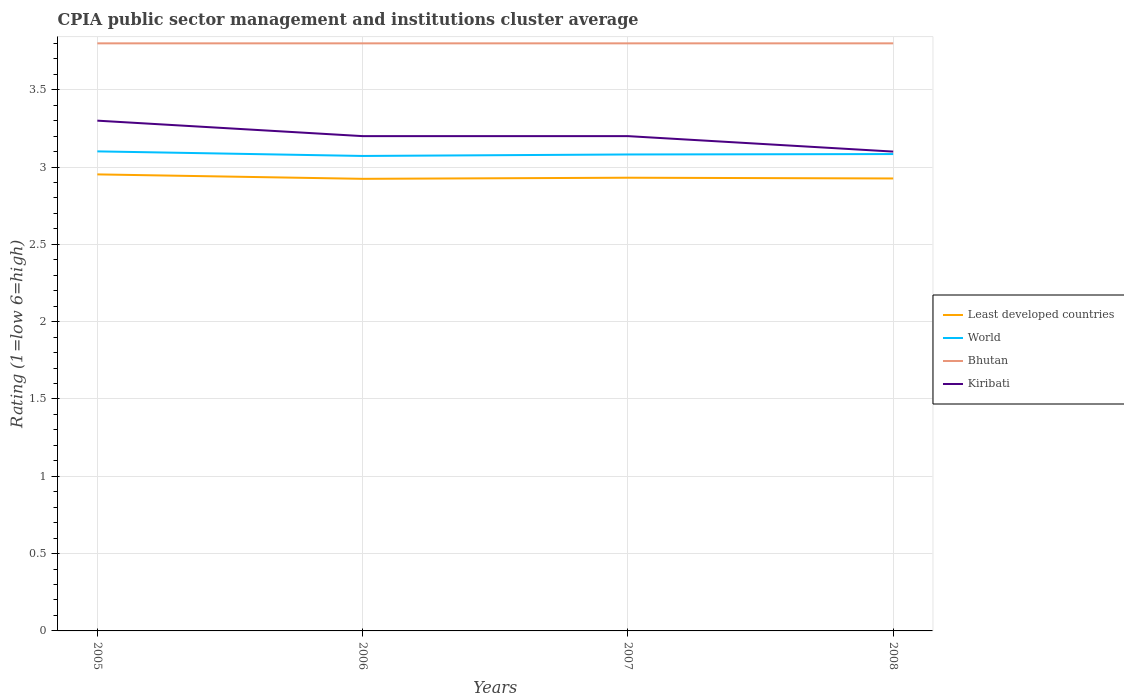How many different coloured lines are there?
Make the answer very short. 4. Does the line corresponding to Kiribati intersect with the line corresponding to World?
Keep it short and to the point. No. Across all years, what is the maximum CPIA rating in World?
Keep it short and to the point. 3.07. What is the total CPIA rating in Least developed countries in the graph?
Your answer should be very brief. -0. What is the difference between the highest and the second highest CPIA rating in Bhutan?
Keep it short and to the point. 0. Is the CPIA rating in Least developed countries strictly greater than the CPIA rating in World over the years?
Keep it short and to the point. Yes. How many lines are there?
Offer a very short reply. 4. How many years are there in the graph?
Provide a succinct answer. 4. What is the difference between two consecutive major ticks on the Y-axis?
Your response must be concise. 0.5. Where does the legend appear in the graph?
Offer a very short reply. Center right. What is the title of the graph?
Your answer should be compact. CPIA public sector management and institutions cluster average. What is the label or title of the X-axis?
Your answer should be compact. Years. What is the label or title of the Y-axis?
Your answer should be very brief. Rating (1=low 6=high). What is the Rating (1=low 6=high) of Least developed countries in 2005?
Ensure brevity in your answer.  2.95. What is the Rating (1=low 6=high) of World in 2005?
Provide a succinct answer. 3.1. What is the Rating (1=low 6=high) of Least developed countries in 2006?
Provide a short and direct response. 2.92. What is the Rating (1=low 6=high) in World in 2006?
Your answer should be compact. 3.07. What is the Rating (1=low 6=high) of Bhutan in 2006?
Your answer should be very brief. 3.8. What is the Rating (1=low 6=high) of Least developed countries in 2007?
Give a very brief answer. 2.93. What is the Rating (1=low 6=high) in World in 2007?
Ensure brevity in your answer.  3.08. What is the Rating (1=low 6=high) in Kiribati in 2007?
Your response must be concise. 3.2. What is the Rating (1=low 6=high) of Least developed countries in 2008?
Your answer should be very brief. 2.93. What is the Rating (1=low 6=high) of World in 2008?
Make the answer very short. 3.08. Across all years, what is the maximum Rating (1=low 6=high) of Least developed countries?
Provide a succinct answer. 2.95. Across all years, what is the maximum Rating (1=low 6=high) in World?
Offer a terse response. 3.1. Across all years, what is the maximum Rating (1=low 6=high) in Bhutan?
Offer a very short reply. 3.8. Across all years, what is the maximum Rating (1=low 6=high) of Kiribati?
Your response must be concise. 3.3. Across all years, what is the minimum Rating (1=low 6=high) in Least developed countries?
Give a very brief answer. 2.92. Across all years, what is the minimum Rating (1=low 6=high) in World?
Provide a succinct answer. 3.07. What is the total Rating (1=low 6=high) in Least developed countries in the graph?
Your response must be concise. 11.73. What is the total Rating (1=low 6=high) of World in the graph?
Your response must be concise. 12.34. What is the difference between the Rating (1=low 6=high) in Least developed countries in 2005 and that in 2006?
Offer a very short reply. 0.03. What is the difference between the Rating (1=low 6=high) in World in 2005 and that in 2006?
Your answer should be compact. 0.03. What is the difference between the Rating (1=low 6=high) in Bhutan in 2005 and that in 2006?
Provide a short and direct response. 0. What is the difference between the Rating (1=low 6=high) in Least developed countries in 2005 and that in 2007?
Make the answer very short. 0.02. What is the difference between the Rating (1=low 6=high) in World in 2005 and that in 2007?
Give a very brief answer. 0.02. What is the difference between the Rating (1=low 6=high) in Bhutan in 2005 and that in 2007?
Ensure brevity in your answer.  0. What is the difference between the Rating (1=low 6=high) of Kiribati in 2005 and that in 2007?
Provide a short and direct response. 0.1. What is the difference between the Rating (1=low 6=high) of Least developed countries in 2005 and that in 2008?
Give a very brief answer. 0.03. What is the difference between the Rating (1=low 6=high) in World in 2005 and that in 2008?
Provide a succinct answer. 0.02. What is the difference between the Rating (1=low 6=high) in Bhutan in 2005 and that in 2008?
Give a very brief answer. 0. What is the difference between the Rating (1=low 6=high) of Least developed countries in 2006 and that in 2007?
Your answer should be very brief. -0.01. What is the difference between the Rating (1=low 6=high) of World in 2006 and that in 2007?
Offer a terse response. -0.01. What is the difference between the Rating (1=low 6=high) of Bhutan in 2006 and that in 2007?
Your answer should be very brief. 0. What is the difference between the Rating (1=low 6=high) of Kiribati in 2006 and that in 2007?
Offer a terse response. 0. What is the difference between the Rating (1=low 6=high) of Least developed countries in 2006 and that in 2008?
Offer a very short reply. -0. What is the difference between the Rating (1=low 6=high) of World in 2006 and that in 2008?
Provide a short and direct response. -0.01. What is the difference between the Rating (1=low 6=high) in Kiribati in 2006 and that in 2008?
Your response must be concise. 0.1. What is the difference between the Rating (1=low 6=high) in Least developed countries in 2007 and that in 2008?
Your response must be concise. 0. What is the difference between the Rating (1=low 6=high) in World in 2007 and that in 2008?
Offer a very short reply. -0. What is the difference between the Rating (1=low 6=high) in Bhutan in 2007 and that in 2008?
Your response must be concise. 0. What is the difference between the Rating (1=low 6=high) in Least developed countries in 2005 and the Rating (1=low 6=high) in World in 2006?
Your answer should be compact. -0.12. What is the difference between the Rating (1=low 6=high) of Least developed countries in 2005 and the Rating (1=low 6=high) of Bhutan in 2006?
Give a very brief answer. -0.85. What is the difference between the Rating (1=low 6=high) in Least developed countries in 2005 and the Rating (1=low 6=high) in Kiribati in 2006?
Your answer should be compact. -0.25. What is the difference between the Rating (1=low 6=high) in World in 2005 and the Rating (1=low 6=high) in Bhutan in 2006?
Your response must be concise. -0.7. What is the difference between the Rating (1=low 6=high) in World in 2005 and the Rating (1=low 6=high) in Kiribati in 2006?
Provide a succinct answer. -0.1. What is the difference between the Rating (1=low 6=high) in Least developed countries in 2005 and the Rating (1=low 6=high) in World in 2007?
Provide a succinct answer. -0.13. What is the difference between the Rating (1=low 6=high) of Least developed countries in 2005 and the Rating (1=low 6=high) of Bhutan in 2007?
Provide a succinct answer. -0.85. What is the difference between the Rating (1=low 6=high) of Least developed countries in 2005 and the Rating (1=low 6=high) of Kiribati in 2007?
Give a very brief answer. -0.25. What is the difference between the Rating (1=low 6=high) in World in 2005 and the Rating (1=low 6=high) in Bhutan in 2007?
Ensure brevity in your answer.  -0.7. What is the difference between the Rating (1=low 6=high) in World in 2005 and the Rating (1=low 6=high) in Kiribati in 2007?
Provide a short and direct response. -0.1. What is the difference between the Rating (1=low 6=high) in Least developed countries in 2005 and the Rating (1=low 6=high) in World in 2008?
Give a very brief answer. -0.13. What is the difference between the Rating (1=low 6=high) of Least developed countries in 2005 and the Rating (1=low 6=high) of Bhutan in 2008?
Make the answer very short. -0.85. What is the difference between the Rating (1=low 6=high) of Least developed countries in 2005 and the Rating (1=low 6=high) of Kiribati in 2008?
Make the answer very short. -0.15. What is the difference between the Rating (1=low 6=high) of World in 2005 and the Rating (1=low 6=high) of Bhutan in 2008?
Provide a short and direct response. -0.7. What is the difference between the Rating (1=low 6=high) in World in 2005 and the Rating (1=low 6=high) in Kiribati in 2008?
Offer a very short reply. 0. What is the difference between the Rating (1=low 6=high) in Bhutan in 2005 and the Rating (1=low 6=high) in Kiribati in 2008?
Ensure brevity in your answer.  0.7. What is the difference between the Rating (1=low 6=high) of Least developed countries in 2006 and the Rating (1=low 6=high) of World in 2007?
Provide a short and direct response. -0.16. What is the difference between the Rating (1=low 6=high) of Least developed countries in 2006 and the Rating (1=low 6=high) of Bhutan in 2007?
Provide a short and direct response. -0.88. What is the difference between the Rating (1=low 6=high) of Least developed countries in 2006 and the Rating (1=low 6=high) of Kiribati in 2007?
Ensure brevity in your answer.  -0.28. What is the difference between the Rating (1=low 6=high) of World in 2006 and the Rating (1=low 6=high) of Bhutan in 2007?
Your answer should be very brief. -0.73. What is the difference between the Rating (1=low 6=high) of World in 2006 and the Rating (1=low 6=high) of Kiribati in 2007?
Provide a short and direct response. -0.13. What is the difference between the Rating (1=low 6=high) in Bhutan in 2006 and the Rating (1=low 6=high) in Kiribati in 2007?
Your response must be concise. 0.6. What is the difference between the Rating (1=low 6=high) in Least developed countries in 2006 and the Rating (1=low 6=high) in World in 2008?
Offer a very short reply. -0.16. What is the difference between the Rating (1=low 6=high) of Least developed countries in 2006 and the Rating (1=low 6=high) of Bhutan in 2008?
Provide a short and direct response. -0.88. What is the difference between the Rating (1=low 6=high) in Least developed countries in 2006 and the Rating (1=low 6=high) in Kiribati in 2008?
Provide a short and direct response. -0.18. What is the difference between the Rating (1=low 6=high) of World in 2006 and the Rating (1=low 6=high) of Bhutan in 2008?
Offer a terse response. -0.73. What is the difference between the Rating (1=low 6=high) in World in 2006 and the Rating (1=low 6=high) in Kiribati in 2008?
Your response must be concise. -0.03. What is the difference between the Rating (1=low 6=high) in Bhutan in 2006 and the Rating (1=low 6=high) in Kiribati in 2008?
Ensure brevity in your answer.  0.7. What is the difference between the Rating (1=low 6=high) in Least developed countries in 2007 and the Rating (1=low 6=high) in World in 2008?
Provide a succinct answer. -0.15. What is the difference between the Rating (1=low 6=high) of Least developed countries in 2007 and the Rating (1=low 6=high) of Bhutan in 2008?
Offer a terse response. -0.87. What is the difference between the Rating (1=low 6=high) in Least developed countries in 2007 and the Rating (1=low 6=high) in Kiribati in 2008?
Offer a terse response. -0.17. What is the difference between the Rating (1=low 6=high) of World in 2007 and the Rating (1=low 6=high) of Bhutan in 2008?
Your response must be concise. -0.72. What is the difference between the Rating (1=low 6=high) in World in 2007 and the Rating (1=low 6=high) in Kiribati in 2008?
Make the answer very short. -0.02. What is the difference between the Rating (1=low 6=high) in Bhutan in 2007 and the Rating (1=low 6=high) in Kiribati in 2008?
Your answer should be compact. 0.7. What is the average Rating (1=low 6=high) of Least developed countries per year?
Give a very brief answer. 2.93. What is the average Rating (1=low 6=high) of World per year?
Your answer should be compact. 3.08. What is the average Rating (1=low 6=high) of Kiribati per year?
Ensure brevity in your answer.  3.2. In the year 2005, what is the difference between the Rating (1=low 6=high) of Least developed countries and Rating (1=low 6=high) of World?
Keep it short and to the point. -0.15. In the year 2005, what is the difference between the Rating (1=low 6=high) of Least developed countries and Rating (1=low 6=high) of Bhutan?
Provide a succinct answer. -0.85. In the year 2005, what is the difference between the Rating (1=low 6=high) in Least developed countries and Rating (1=low 6=high) in Kiribati?
Keep it short and to the point. -0.35. In the year 2005, what is the difference between the Rating (1=low 6=high) of World and Rating (1=low 6=high) of Bhutan?
Provide a succinct answer. -0.7. In the year 2005, what is the difference between the Rating (1=low 6=high) of World and Rating (1=low 6=high) of Kiribati?
Your answer should be very brief. -0.2. In the year 2006, what is the difference between the Rating (1=low 6=high) in Least developed countries and Rating (1=low 6=high) in World?
Your answer should be very brief. -0.15. In the year 2006, what is the difference between the Rating (1=low 6=high) of Least developed countries and Rating (1=low 6=high) of Bhutan?
Your answer should be compact. -0.88. In the year 2006, what is the difference between the Rating (1=low 6=high) in Least developed countries and Rating (1=low 6=high) in Kiribati?
Your answer should be compact. -0.28. In the year 2006, what is the difference between the Rating (1=low 6=high) in World and Rating (1=low 6=high) in Bhutan?
Provide a succinct answer. -0.73. In the year 2006, what is the difference between the Rating (1=low 6=high) of World and Rating (1=low 6=high) of Kiribati?
Ensure brevity in your answer.  -0.13. In the year 2006, what is the difference between the Rating (1=low 6=high) in Bhutan and Rating (1=low 6=high) in Kiribati?
Ensure brevity in your answer.  0.6. In the year 2007, what is the difference between the Rating (1=low 6=high) in Least developed countries and Rating (1=low 6=high) in World?
Provide a succinct answer. -0.15. In the year 2007, what is the difference between the Rating (1=low 6=high) in Least developed countries and Rating (1=low 6=high) in Bhutan?
Offer a terse response. -0.87. In the year 2007, what is the difference between the Rating (1=low 6=high) of Least developed countries and Rating (1=low 6=high) of Kiribati?
Your response must be concise. -0.27. In the year 2007, what is the difference between the Rating (1=low 6=high) in World and Rating (1=low 6=high) in Bhutan?
Keep it short and to the point. -0.72. In the year 2007, what is the difference between the Rating (1=low 6=high) in World and Rating (1=low 6=high) in Kiribati?
Keep it short and to the point. -0.12. In the year 2008, what is the difference between the Rating (1=low 6=high) in Least developed countries and Rating (1=low 6=high) in World?
Make the answer very short. -0.16. In the year 2008, what is the difference between the Rating (1=low 6=high) of Least developed countries and Rating (1=low 6=high) of Bhutan?
Make the answer very short. -0.87. In the year 2008, what is the difference between the Rating (1=low 6=high) in Least developed countries and Rating (1=low 6=high) in Kiribati?
Provide a succinct answer. -0.17. In the year 2008, what is the difference between the Rating (1=low 6=high) of World and Rating (1=low 6=high) of Bhutan?
Provide a succinct answer. -0.72. In the year 2008, what is the difference between the Rating (1=low 6=high) of World and Rating (1=low 6=high) of Kiribati?
Provide a succinct answer. -0.02. In the year 2008, what is the difference between the Rating (1=low 6=high) of Bhutan and Rating (1=low 6=high) of Kiribati?
Offer a terse response. 0.7. What is the ratio of the Rating (1=low 6=high) in Least developed countries in 2005 to that in 2006?
Your response must be concise. 1.01. What is the ratio of the Rating (1=low 6=high) in World in 2005 to that in 2006?
Offer a terse response. 1.01. What is the ratio of the Rating (1=low 6=high) in Bhutan in 2005 to that in 2006?
Make the answer very short. 1. What is the ratio of the Rating (1=low 6=high) of Kiribati in 2005 to that in 2006?
Your answer should be very brief. 1.03. What is the ratio of the Rating (1=low 6=high) in Least developed countries in 2005 to that in 2007?
Your answer should be compact. 1.01. What is the ratio of the Rating (1=low 6=high) in World in 2005 to that in 2007?
Offer a terse response. 1.01. What is the ratio of the Rating (1=low 6=high) in Bhutan in 2005 to that in 2007?
Your response must be concise. 1. What is the ratio of the Rating (1=low 6=high) of Kiribati in 2005 to that in 2007?
Keep it short and to the point. 1.03. What is the ratio of the Rating (1=low 6=high) of World in 2005 to that in 2008?
Make the answer very short. 1.01. What is the ratio of the Rating (1=low 6=high) of Bhutan in 2005 to that in 2008?
Ensure brevity in your answer.  1. What is the ratio of the Rating (1=low 6=high) of Kiribati in 2005 to that in 2008?
Provide a short and direct response. 1.06. What is the ratio of the Rating (1=low 6=high) of Least developed countries in 2006 to that in 2007?
Provide a succinct answer. 1. What is the ratio of the Rating (1=low 6=high) of Bhutan in 2006 to that in 2008?
Your answer should be compact. 1. What is the ratio of the Rating (1=low 6=high) in Kiribati in 2006 to that in 2008?
Make the answer very short. 1.03. What is the ratio of the Rating (1=low 6=high) in Least developed countries in 2007 to that in 2008?
Offer a terse response. 1. What is the ratio of the Rating (1=low 6=high) of Bhutan in 2007 to that in 2008?
Provide a succinct answer. 1. What is the ratio of the Rating (1=low 6=high) in Kiribati in 2007 to that in 2008?
Keep it short and to the point. 1.03. What is the difference between the highest and the second highest Rating (1=low 6=high) of Least developed countries?
Offer a very short reply. 0.02. What is the difference between the highest and the second highest Rating (1=low 6=high) in World?
Provide a short and direct response. 0.02. What is the difference between the highest and the second highest Rating (1=low 6=high) of Bhutan?
Ensure brevity in your answer.  0. What is the difference between the highest and the lowest Rating (1=low 6=high) in Least developed countries?
Your response must be concise. 0.03. What is the difference between the highest and the lowest Rating (1=low 6=high) in World?
Keep it short and to the point. 0.03. What is the difference between the highest and the lowest Rating (1=low 6=high) of Kiribati?
Provide a short and direct response. 0.2. 